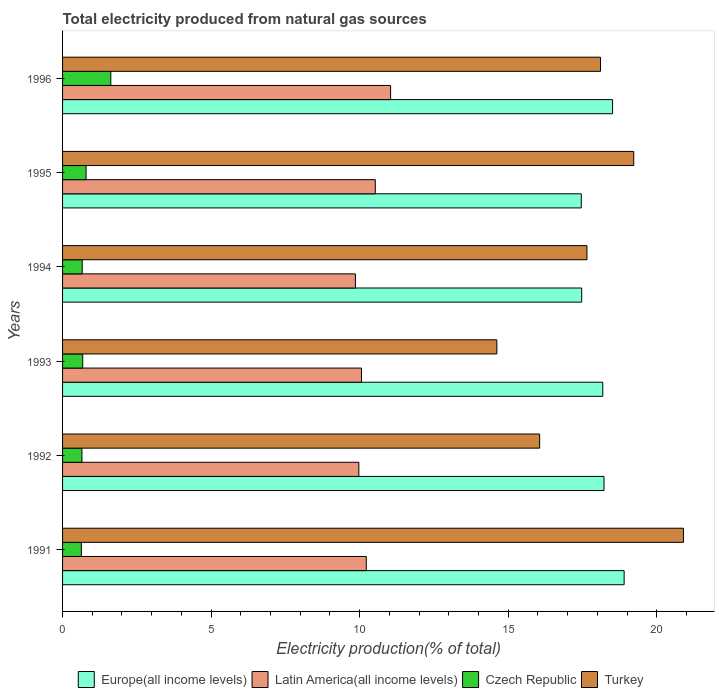How many different coloured bars are there?
Your answer should be very brief. 4. How many groups of bars are there?
Provide a short and direct response. 6. Are the number of bars per tick equal to the number of legend labels?
Your answer should be very brief. Yes. Are the number of bars on each tick of the Y-axis equal?
Your answer should be very brief. Yes. How many bars are there on the 3rd tick from the top?
Ensure brevity in your answer.  4. How many bars are there on the 2nd tick from the bottom?
Provide a short and direct response. 4. What is the label of the 1st group of bars from the top?
Offer a terse response. 1996. In how many cases, is the number of bars for a given year not equal to the number of legend labels?
Offer a very short reply. 0. What is the total electricity produced in Latin America(all income levels) in 1991?
Your answer should be very brief. 10.22. Across all years, what is the maximum total electricity produced in Czech Republic?
Offer a very short reply. 1.62. Across all years, what is the minimum total electricity produced in Turkey?
Your response must be concise. 14.62. In which year was the total electricity produced in Latin America(all income levels) minimum?
Offer a terse response. 1994. What is the total total electricity produced in Latin America(all income levels) in the graph?
Provide a short and direct response. 61.68. What is the difference between the total electricity produced in Turkey in 1991 and that in 1994?
Give a very brief answer. 3.25. What is the difference between the total electricity produced in Latin America(all income levels) in 1994 and the total electricity produced in Czech Republic in 1996?
Provide a succinct answer. 8.23. What is the average total electricity produced in Turkey per year?
Your answer should be compact. 17.76. In the year 1991, what is the difference between the total electricity produced in Czech Republic and total electricity produced in Europe(all income levels)?
Your answer should be compact. -18.27. In how many years, is the total electricity produced in Turkey greater than 12 %?
Ensure brevity in your answer.  6. What is the ratio of the total electricity produced in Latin America(all income levels) in 1992 to that in 1994?
Keep it short and to the point. 1.01. Is the difference between the total electricity produced in Czech Republic in 1991 and 1996 greater than the difference between the total electricity produced in Europe(all income levels) in 1991 and 1996?
Ensure brevity in your answer.  No. What is the difference between the highest and the second highest total electricity produced in Czech Republic?
Offer a very short reply. 0.83. What is the difference between the highest and the lowest total electricity produced in Czech Republic?
Provide a succinct answer. 0.99. In how many years, is the total electricity produced in Latin America(all income levels) greater than the average total electricity produced in Latin America(all income levels) taken over all years?
Provide a short and direct response. 2. Is it the case that in every year, the sum of the total electricity produced in Latin America(all income levels) and total electricity produced in Czech Republic is greater than the sum of total electricity produced in Turkey and total electricity produced in Europe(all income levels)?
Provide a short and direct response. No. What does the 2nd bar from the top in 1991 represents?
Give a very brief answer. Czech Republic. What does the 1st bar from the bottom in 1994 represents?
Your answer should be very brief. Europe(all income levels). What is the difference between two consecutive major ticks on the X-axis?
Your answer should be very brief. 5. Are the values on the major ticks of X-axis written in scientific E-notation?
Provide a short and direct response. No. How many legend labels are there?
Your answer should be very brief. 4. What is the title of the graph?
Keep it short and to the point. Total electricity produced from natural gas sources. What is the label or title of the X-axis?
Give a very brief answer. Electricity production(% of total). What is the Electricity production(% of total) of Europe(all income levels) in 1991?
Make the answer very short. 18.9. What is the Electricity production(% of total) of Latin America(all income levels) in 1991?
Keep it short and to the point. 10.22. What is the Electricity production(% of total) in Czech Republic in 1991?
Give a very brief answer. 0.63. What is the Electricity production(% of total) of Turkey in 1991?
Offer a very short reply. 20.9. What is the Electricity production(% of total) of Europe(all income levels) in 1992?
Make the answer very short. 18.22. What is the Electricity production(% of total) in Latin America(all income levels) in 1992?
Your answer should be very brief. 9.97. What is the Electricity production(% of total) of Czech Republic in 1992?
Your response must be concise. 0.65. What is the Electricity production(% of total) of Turkey in 1992?
Your answer should be compact. 16.06. What is the Electricity production(% of total) of Europe(all income levels) in 1993?
Offer a terse response. 18.18. What is the Electricity production(% of total) of Latin America(all income levels) in 1993?
Keep it short and to the point. 10.06. What is the Electricity production(% of total) in Czech Republic in 1993?
Keep it short and to the point. 0.68. What is the Electricity production(% of total) of Turkey in 1993?
Keep it short and to the point. 14.62. What is the Electricity production(% of total) of Europe(all income levels) in 1994?
Your response must be concise. 17.47. What is the Electricity production(% of total) of Latin America(all income levels) in 1994?
Make the answer very short. 9.86. What is the Electricity production(% of total) in Czech Republic in 1994?
Provide a succinct answer. 0.66. What is the Electricity production(% of total) in Turkey in 1994?
Your response must be concise. 17.65. What is the Electricity production(% of total) of Europe(all income levels) in 1995?
Give a very brief answer. 17.46. What is the Electricity production(% of total) of Latin America(all income levels) in 1995?
Make the answer very short. 10.53. What is the Electricity production(% of total) in Czech Republic in 1995?
Provide a succinct answer. 0.79. What is the Electricity production(% of total) in Turkey in 1995?
Make the answer very short. 19.22. What is the Electricity production(% of total) of Europe(all income levels) in 1996?
Your response must be concise. 18.51. What is the Electricity production(% of total) in Latin America(all income levels) in 1996?
Ensure brevity in your answer.  11.04. What is the Electricity production(% of total) of Czech Republic in 1996?
Your answer should be very brief. 1.62. What is the Electricity production(% of total) in Turkey in 1996?
Make the answer very short. 18.1. Across all years, what is the maximum Electricity production(% of total) in Europe(all income levels)?
Make the answer very short. 18.9. Across all years, what is the maximum Electricity production(% of total) in Latin America(all income levels)?
Your response must be concise. 11.04. Across all years, what is the maximum Electricity production(% of total) in Czech Republic?
Your answer should be very brief. 1.62. Across all years, what is the maximum Electricity production(% of total) in Turkey?
Offer a terse response. 20.9. Across all years, what is the minimum Electricity production(% of total) of Europe(all income levels)?
Offer a very short reply. 17.46. Across all years, what is the minimum Electricity production(% of total) in Latin America(all income levels)?
Ensure brevity in your answer.  9.86. Across all years, what is the minimum Electricity production(% of total) of Czech Republic?
Ensure brevity in your answer.  0.63. Across all years, what is the minimum Electricity production(% of total) in Turkey?
Your answer should be compact. 14.62. What is the total Electricity production(% of total) in Europe(all income levels) in the graph?
Make the answer very short. 108.74. What is the total Electricity production(% of total) in Latin America(all income levels) in the graph?
Offer a terse response. 61.68. What is the total Electricity production(% of total) in Czech Republic in the graph?
Provide a short and direct response. 5.04. What is the total Electricity production(% of total) in Turkey in the graph?
Keep it short and to the point. 106.54. What is the difference between the Electricity production(% of total) in Europe(all income levels) in 1991 and that in 1992?
Provide a succinct answer. 0.68. What is the difference between the Electricity production(% of total) in Latin America(all income levels) in 1991 and that in 1992?
Give a very brief answer. 0.25. What is the difference between the Electricity production(% of total) in Czech Republic in 1991 and that in 1992?
Keep it short and to the point. -0.02. What is the difference between the Electricity production(% of total) of Turkey in 1991 and that in 1992?
Make the answer very short. 4.84. What is the difference between the Electricity production(% of total) in Europe(all income levels) in 1991 and that in 1993?
Your response must be concise. 0.72. What is the difference between the Electricity production(% of total) of Latin America(all income levels) in 1991 and that in 1993?
Make the answer very short. 0.16. What is the difference between the Electricity production(% of total) in Czech Republic in 1991 and that in 1993?
Offer a very short reply. -0.05. What is the difference between the Electricity production(% of total) of Turkey in 1991 and that in 1993?
Provide a short and direct response. 6.28. What is the difference between the Electricity production(% of total) of Europe(all income levels) in 1991 and that in 1994?
Ensure brevity in your answer.  1.43. What is the difference between the Electricity production(% of total) of Latin America(all income levels) in 1991 and that in 1994?
Your answer should be very brief. 0.37. What is the difference between the Electricity production(% of total) in Czech Republic in 1991 and that in 1994?
Your answer should be very brief. -0.03. What is the difference between the Electricity production(% of total) in Turkey in 1991 and that in 1994?
Your answer should be compact. 3.25. What is the difference between the Electricity production(% of total) in Europe(all income levels) in 1991 and that in 1995?
Your response must be concise. 1.44. What is the difference between the Electricity production(% of total) of Latin America(all income levels) in 1991 and that in 1995?
Give a very brief answer. -0.3. What is the difference between the Electricity production(% of total) of Czech Republic in 1991 and that in 1995?
Your response must be concise. -0.16. What is the difference between the Electricity production(% of total) in Turkey in 1991 and that in 1995?
Offer a terse response. 1.67. What is the difference between the Electricity production(% of total) in Europe(all income levels) in 1991 and that in 1996?
Provide a short and direct response. 0.39. What is the difference between the Electricity production(% of total) of Latin America(all income levels) in 1991 and that in 1996?
Your response must be concise. -0.82. What is the difference between the Electricity production(% of total) of Czech Republic in 1991 and that in 1996?
Provide a succinct answer. -0.99. What is the difference between the Electricity production(% of total) of Turkey in 1991 and that in 1996?
Keep it short and to the point. 2.79. What is the difference between the Electricity production(% of total) of Europe(all income levels) in 1992 and that in 1993?
Your response must be concise. 0.04. What is the difference between the Electricity production(% of total) of Latin America(all income levels) in 1992 and that in 1993?
Make the answer very short. -0.09. What is the difference between the Electricity production(% of total) in Czech Republic in 1992 and that in 1993?
Offer a terse response. -0.03. What is the difference between the Electricity production(% of total) of Turkey in 1992 and that in 1993?
Your answer should be very brief. 1.44. What is the difference between the Electricity production(% of total) in Europe(all income levels) in 1992 and that in 1994?
Offer a terse response. 0.75. What is the difference between the Electricity production(% of total) of Latin America(all income levels) in 1992 and that in 1994?
Provide a succinct answer. 0.12. What is the difference between the Electricity production(% of total) of Czech Republic in 1992 and that in 1994?
Your answer should be compact. -0.01. What is the difference between the Electricity production(% of total) in Turkey in 1992 and that in 1994?
Provide a short and direct response. -1.59. What is the difference between the Electricity production(% of total) in Europe(all income levels) in 1992 and that in 1995?
Offer a terse response. 0.77. What is the difference between the Electricity production(% of total) of Latin America(all income levels) in 1992 and that in 1995?
Provide a succinct answer. -0.55. What is the difference between the Electricity production(% of total) of Czech Republic in 1992 and that in 1995?
Provide a short and direct response. -0.14. What is the difference between the Electricity production(% of total) in Turkey in 1992 and that in 1995?
Your answer should be very brief. -3.17. What is the difference between the Electricity production(% of total) in Europe(all income levels) in 1992 and that in 1996?
Your answer should be compact. -0.29. What is the difference between the Electricity production(% of total) of Latin America(all income levels) in 1992 and that in 1996?
Your response must be concise. -1.07. What is the difference between the Electricity production(% of total) of Czech Republic in 1992 and that in 1996?
Offer a very short reply. -0.97. What is the difference between the Electricity production(% of total) of Turkey in 1992 and that in 1996?
Your answer should be compact. -2.05. What is the difference between the Electricity production(% of total) of Europe(all income levels) in 1993 and that in 1994?
Your response must be concise. 0.71. What is the difference between the Electricity production(% of total) of Latin America(all income levels) in 1993 and that in 1994?
Your response must be concise. 0.2. What is the difference between the Electricity production(% of total) in Czech Republic in 1993 and that in 1994?
Provide a short and direct response. 0.02. What is the difference between the Electricity production(% of total) of Turkey in 1993 and that in 1994?
Give a very brief answer. -3.03. What is the difference between the Electricity production(% of total) in Europe(all income levels) in 1993 and that in 1995?
Keep it short and to the point. 0.72. What is the difference between the Electricity production(% of total) in Latin America(all income levels) in 1993 and that in 1995?
Your answer should be very brief. -0.47. What is the difference between the Electricity production(% of total) of Czech Republic in 1993 and that in 1995?
Offer a very short reply. -0.11. What is the difference between the Electricity production(% of total) in Turkey in 1993 and that in 1995?
Your response must be concise. -4.61. What is the difference between the Electricity production(% of total) in Europe(all income levels) in 1993 and that in 1996?
Give a very brief answer. -0.33. What is the difference between the Electricity production(% of total) in Latin America(all income levels) in 1993 and that in 1996?
Your answer should be compact. -0.98. What is the difference between the Electricity production(% of total) in Czech Republic in 1993 and that in 1996?
Provide a short and direct response. -0.94. What is the difference between the Electricity production(% of total) in Turkey in 1993 and that in 1996?
Give a very brief answer. -3.49. What is the difference between the Electricity production(% of total) in Europe(all income levels) in 1994 and that in 1995?
Provide a short and direct response. 0.01. What is the difference between the Electricity production(% of total) of Latin America(all income levels) in 1994 and that in 1995?
Give a very brief answer. -0.67. What is the difference between the Electricity production(% of total) in Czech Republic in 1994 and that in 1995?
Give a very brief answer. -0.13. What is the difference between the Electricity production(% of total) in Turkey in 1994 and that in 1995?
Make the answer very short. -1.57. What is the difference between the Electricity production(% of total) in Europe(all income levels) in 1994 and that in 1996?
Offer a very short reply. -1.04. What is the difference between the Electricity production(% of total) in Latin America(all income levels) in 1994 and that in 1996?
Offer a terse response. -1.18. What is the difference between the Electricity production(% of total) of Czech Republic in 1994 and that in 1996?
Offer a terse response. -0.96. What is the difference between the Electricity production(% of total) in Turkey in 1994 and that in 1996?
Keep it short and to the point. -0.46. What is the difference between the Electricity production(% of total) in Europe(all income levels) in 1995 and that in 1996?
Provide a succinct answer. -1.05. What is the difference between the Electricity production(% of total) in Latin America(all income levels) in 1995 and that in 1996?
Provide a short and direct response. -0.52. What is the difference between the Electricity production(% of total) in Czech Republic in 1995 and that in 1996?
Your answer should be compact. -0.83. What is the difference between the Electricity production(% of total) of Turkey in 1995 and that in 1996?
Make the answer very short. 1.12. What is the difference between the Electricity production(% of total) of Europe(all income levels) in 1991 and the Electricity production(% of total) of Latin America(all income levels) in 1992?
Offer a very short reply. 8.93. What is the difference between the Electricity production(% of total) of Europe(all income levels) in 1991 and the Electricity production(% of total) of Czech Republic in 1992?
Offer a terse response. 18.25. What is the difference between the Electricity production(% of total) of Europe(all income levels) in 1991 and the Electricity production(% of total) of Turkey in 1992?
Your answer should be very brief. 2.84. What is the difference between the Electricity production(% of total) of Latin America(all income levels) in 1991 and the Electricity production(% of total) of Czech Republic in 1992?
Offer a very short reply. 9.57. What is the difference between the Electricity production(% of total) of Latin America(all income levels) in 1991 and the Electricity production(% of total) of Turkey in 1992?
Your answer should be compact. -5.84. What is the difference between the Electricity production(% of total) of Czech Republic in 1991 and the Electricity production(% of total) of Turkey in 1992?
Make the answer very short. -15.43. What is the difference between the Electricity production(% of total) of Europe(all income levels) in 1991 and the Electricity production(% of total) of Latin America(all income levels) in 1993?
Provide a short and direct response. 8.84. What is the difference between the Electricity production(% of total) of Europe(all income levels) in 1991 and the Electricity production(% of total) of Czech Republic in 1993?
Your answer should be very brief. 18.22. What is the difference between the Electricity production(% of total) in Europe(all income levels) in 1991 and the Electricity production(% of total) in Turkey in 1993?
Give a very brief answer. 4.28. What is the difference between the Electricity production(% of total) of Latin America(all income levels) in 1991 and the Electricity production(% of total) of Czech Republic in 1993?
Provide a succinct answer. 9.54. What is the difference between the Electricity production(% of total) in Latin America(all income levels) in 1991 and the Electricity production(% of total) in Turkey in 1993?
Provide a succinct answer. -4.39. What is the difference between the Electricity production(% of total) in Czech Republic in 1991 and the Electricity production(% of total) in Turkey in 1993?
Give a very brief answer. -13.98. What is the difference between the Electricity production(% of total) of Europe(all income levels) in 1991 and the Electricity production(% of total) of Latin America(all income levels) in 1994?
Give a very brief answer. 9.04. What is the difference between the Electricity production(% of total) in Europe(all income levels) in 1991 and the Electricity production(% of total) in Czech Republic in 1994?
Keep it short and to the point. 18.24. What is the difference between the Electricity production(% of total) in Europe(all income levels) in 1991 and the Electricity production(% of total) in Turkey in 1994?
Make the answer very short. 1.25. What is the difference between the Electricity production(% of total) of Latin America(all income levels) in 1991 and the Electricity production(% of total) of Czech Republic in 1994?
Your answer should be very brief. 9.56. What is the difference between the Electricity production(% of total) of Latin America(all income levels) in 1991 and the Electricity production(% of total) of Turkey in 1994?
Provide a succinct answer. -7.43. What is the difference between the Electricity production(% of total) in Czech Republic in 1991 and the Electricity production(% of total) in Turkey in 1994?
Offer a terse response. -17.02. What is the difference between the Electricity production(% of total) of Europe(all income levels) in 1991 and the Electricity production(% of total) of Latin America(all income levels) in 1995?
Your answer should be very brief. 8.37. What is the difference between the Electricity production(% of total) in Europe(all income levels) in 1991 and the Electricity production(% of total) in Czech Republic in 1995?
Keep it short and to the point. 18.11. What is the difference between the Electricity production(% of total) in Europe(all income levels) in 1991 and the Electricity production(% of total) in Turkey in 1995?
Offer a terse response. -0.32. What is the difference between the Electricity production(% of total) of Latin America(all income levels) in 1991 and the Electricity production(% of total) of Czech Republic in 1995?
Your answer should be very brief. 9.43. What is the difference between the Electricity production(% of total) in Latin America(all income levels) in 1991 and the Electricity production(% of total) in Turkey in 1995?
Offer a very short reply. -9. What is the difference between the Electricity production(% of total) of Czech Republic in 1991 and the Electricity production(% of total) of Turkey in 1995?
Give a very brief answer. -18.59. What is the difference between the Electricity production(% of total) of Europe(all income levels) in 1991 and the Electricity production(% of total) of Latin America(all income levels) in 1996?
Give a very brief answer. 7.86. What is the difference between the Electricity production(% of total) of Europe(all income levels) in 1991 and the Electricity production(% of total) of Czech Republic in 1996?
Make the answer very short. 17.28. What is the difference between the Electricity production(% of total) of Europe(all income levels) in 1991 and the Electricity production(% of total) of Turkey in 1996?
Your response must be concise. 0.8. What is the difference between the Electricity production(% of total) of Latin America(all income levels) in 1991 and the Electricity production(% of total) of Czech Republic in 1996?
Provide a succinct answer. 8.6. What is the difference between the Electricity production(% of total) in Latin America(all income levels) in 1991 and the Electricity production(% of total) in Turkey in 1996?
Provide a short and direct response. -7.88. What is the difference between the Electricity production(% of total) of Czech Republic in 1991 and the Electricity production(% of total) of Turkey in 1996?
Give a very brief answer. -17.47. What is the difference between the Electricity production(% of total) of Europe(all income levels) in 1992 and the Electricity production(% of total) of Latin America(all income levels) in 1993?
Provide a succinct answer. 8.16. What is the difference between the Electricity production(% of total) in Europe(all income levels) in 1992 and the Electricity production(% of total) in Czech Republic in 1993?
Offer a very short reply. 17.54. What is the difference between the Electricity production(% of total) in Europe(all income levels) in 1992 and the Electricity production(% of total) in Turkey in 1993?
Your response must be concise. 3.61. What is the difference between the Electricity production(% of total) in Latin America(all income levels) in 1992 and the Electricity production(% of total) in Czech Republic in 1993?
Your answer should be very brief. 9.29. What is the difference between the Electricity production(% of total) of Latin America(all income levels) in 1992 and the Electricity production(% of total) of Turkey in 1993?
Your answer should be compact. -4.64. What is the difference between the Electricity production(% of total) of Czech Republic in 1992 and the Electricity production(% of total) of Turkey in 1993?
Offer a terse response. -13.96. What is the difference between the Electricity production(% of total) of Europe(all income levels) in 1992 and the Electricity production(% of total) of Latin America(all income levels) in 1994?
Ensure brevity in your answer.  8.37. What is the difference between the Electricity production(% of total) of Europe(all income levels) in 1992 and the Electricity production(% of total) of Czech Republic in 1994?
Give a very brief answer. 17.56. What is the difference between the Electricity production(% of total) in Europe(all income levels) in 1992 and the Electricity production(% of total) in Turkey in 1994?
Your answer should be compact. 0.57. What is the difference between the Electricity production(% of total) of Latin America(all income levels) in 1992 and the Electricity production(% of total) of Czech Republic in 1994?
Make the answer very short. 9.31. What is the difference between the Electricity production(% of total) of Latin America(all income levels) in 1992 and the Electricity production(% of total) of Turkey in 1994?
Offer a very short reply. -7.68. What is the difference between the Electricity production(% of total) in Czech Republic in 1992 and the Electricity production(% of total) in Turkey in 1994?
Provide a succinct answer. -17. What is the difference between the Electricity production(% of total) in Europe(all income levels) in 1992 and the Electricity production(% of total) in Latin America(all income levels) in 1995?
Provide a succinct answer. 7.7. What is the difference between the Electricity production(% of total) in Europe(all income levels) in 1992 and the Electricity production(% of total) in Czech Republic in 1995?
Ensure brevity in your answer.  17.43. What is the difference between the Electricity production(% of total) in Europe(all income levels) in 1992 and the Electricity production(% of total) in Turkey in 1995?
Make the answer very short. -1. What is the difference between the Electricity production(% of total) in Latin America(all income levels) in 1992 and the Electricity production(% of total) in Czech Republic in 1995?
Make the answer very short. 9.18. What is the difference between the Electricity production(% of total) of Latin America(all income levels) in 1992 and the Electricity production(% of total) of Turkey in 1995?
Provide a short and direct response. -9.25. What is the difference between the Electricity production(% of total) of Czech Republic in 1992 and the Electricity production(% of total) of Turkey in 1995?
Your answer should be compact. -18.57. What is the difference between the Electricity production(% of total) of Europe(all income levels) in 1992 and the Electricity production(% of total) of Latin America(all income levels) in 1996?
Your response must be concise. 7.18. What is the difference between the Electricity production(% of total) of Europe(all income levels) in 1992 and the Electricity production(% of total) of Czech Republic in 1996?
Your response must be concise. 16.6. What is the difference between the Electricity production(% of total) of Europe(all income levels) in 1992 and the Electricity production(% of total) of Turkey in 1996?
Your answer should be very brief. 0.12. What is the difference between the Electricity production(% of total) in Latin America(all income levels) in 1992 and the Electricity production(% of total) in Czech Republic in 1996?
Provide a short and direct response. 8.35. What is the difference between the Electricity production(% of total) in Latin America(all income levels) in 1992 and the Electricity production(% of total) in Turkey in 1996?
Offer a very short reply. -8.13. What is the difference between the Electricity production(% of total) in Czech Republic in 1992 and the Electricity production(% of total) in Turkey in 1996?
Your answer should be very brief. -17.45. What is the difference between the Electricity production(% of total) of Europe(all income levels) in 1993 and the Electricity production(% of total) of Latin America(all income levels) in 1994?
Your answer should be very brief. 8.33. What is the difference between the Electricity production(% of total) of Europe(all income levels) in 1993 and the Electricity production(% of total) of Czech Republic in 1994?
Offer a very short reply. 17.52. What is the difference between the Electricity production(% of total) of Europe(all income levels) in 1993 and the Electricity production(% of total) of Turkey in 1994?
Give a very brief answer. 0.53. What is the difference between the Electricity production(% of total) of Latin America(all income levels) in 1993 and the Electricity production(% of total) of Czech Republic in 1994?
Ensure brevity in your answer.  9.4. What is the difference between the Electricity production(% of total) in Latin America(all income levels) in 1993 and the Electricity production(% of total) in Turkey in 1994?
Offer a terse response. -7.59. What is the difference between the Electricity production(% of total) of Czech Republic in 1993 and the Electricity production(% of total) of Turkey in 1994?
Your answer should be compact. -16.97. What is the difference between the Electricity production(% of total) of Europe(all income levels) in 1993 and the Electricity production(% of total) of Latin America(all income levels) in 1995?
Provide a succinct answer. 7.66. What is the difference between the Electricity production(% of total) in Europe(all income levels) in 1993 and the Electricity production(% of total) in Czech Republic in 1995?
Your answer should be very brief. 17.39. What is the difference between the Electricity production(% of total) of Europe(all income levels) in 1993 and the Electricity production(% of total) of Turkey in 1995?
Give a very brief answer. -1.04. What is the difference between the Electricity production(% of total) in Latin America(all income levels) in 1993 and the Electricity production(% of total) in Czech Republic in 1995?
Ensure brevity in your answer.  9.27. What is the difference between the Electricity production(% of total) in Latin America(all income levels) in 1993 and the Electricity production(% of total) in Turkey in 1995?
Your answer should be compact. -9.16. What is the difference between the Electricity production(% of total) of Czech Republic in 1993 and the Electricity production(% of total) of Turkey in 1995?
Keep it short and to the point. -18.54. What is the difference between the Electricity production(% of total) in Europe(all income levels) in 1993 and the Electricity production(% of total) in Latin America(all income levels) in 1996?
Ensure brevity in your answer.  7.14. What is the difference between the Electricity production(% of total) of Europe(all income levels) in 1993 and the Electricity production(% of total) of Czech Republic in 1996?
Your answer should be very brief. 16.56. What is the difference between the Electricity production(% of total) in Europe(all income levels) in 1993 and the Electricity production(% of total) in Turkey in 1996?
Make the answer very short. 0.08. What is the difference between the Electricity production(% of total) of Latin America(all income levels) in 1993 and the Electricity production(% of total) of Czech Republic in 1996?
Keep it short and to the point. 8.44. What is the difference between the Electricity production(% of total) in Latin America(all income levels) in 1993 and the Electricity production(% of total) in Turkey in 1996?
Provide a short and direct response. -8.04. What is the difference between the Electricity production(% of total) in Czech Republic in 1993 and the Electricity production(% of total) in Turkey in 1996?
Provide a succinct answer. -17.43. What is the difference between the Electricity production(% of total) of Europe(all income levels) in 1994 and the Electricity production(% of total) of Latin America(all income levels) in 1995?
Your answer should be very brief. 6.95. What is the difference between the Electricity production(% of total) in Europe(all income levels) in 1994 and the Electricity production(% of total) in Czech Republic in 1995?
Make the answer very short. 16.68. What is the difference between the Electricity production(% of total) of Europe(all income levels) in 1994 and the Electricity production(% of total) of Turkey in 1995?
Make the answer very short. -1.75. What is the difference between the Electricity production(% of total) of Latin America(all income levels) in 1994 and the Electricity production(% of total) of Czech Republic in 1995?
Ensure brevity in your answer.  9.07. What is the difference between the Electricity production(% of total) in Latin America(all income levels) in 1994 and the Electricity production(% of total) in Turkey in 1995?
Make the answer very short. -9.37. What is the difference between the Electricity production(% of total) of Czech Republic in 1994 and the Electricity production(% of total) of Turkey in 1995?
Provide a short and direct response. -18.56. What is the difference between the Electricity production(% of total) of Europe(all income levels) in 1994 and the Electricity production(% of total) of Latin America(all income levels) in 1996?
Ensure brevity in your answer.  6.43. What is the difference between the Electricity production(% of total) in Europe(all income levels) in 1994 and the Electricity production(% of total) in Czech Republic in 1996?
Make the answer very short. 15.85. What is the difference between the Electricity production(% of total) of Europe(all income levels) in 1994 and the Electricity production(% of total) of Turkey in 1996?
Your response must be concise. -0.63. What is the difference between the Electricity production(% of total) in Latin America(all income levels) in 1994 and the Electricity production(% of total) in Czech Republic in 1996?
Give a very brief answer. 8.23. What is the difference between the Electricity production(% of total) in Latin America(all income levels) in 1994 and the Electricity production(% of total) in Turkey in 1996?
Ensure brevity in your answer.  -8.25. What is the difference between the Electricity production(% of total) of Czech Republic in 1994 and the Electricity production(% of total) of Turkey in 1996?
Your answer should be very brief. -17.44. What is the difference between the Electricity production(% of total) in Europe(all income levels) in 1995 and the Electricity production(% of total) in Latin America(all income levels) in 1996?
Offer a terse response. 6.42. What is the difference between the Electricity production(% of total) in Europe(all income levels) in 1995 and the Electricity production(% of total) in Czech Republic in 1996?
Your answer should be very brief. 15.83. What is the difference between the Electricity production(% of total) in Europe(all income levels) in 1995 and the Electricity production(% of total) in Turkey in 1996?
Offer a very short reply. -0.65. What is the difference between the Electricity production(% of total) in Latin America(all income levels) in 1995 and the Electricity production(% of total) in Czech Republic in 1996?
Your response must be concise. 8.9. What is the difference between the Electricity production(% of total) of Latin America(all income levels) in 1995 and the Electricity production(% of total) of Turkey in 1996?
Your response must be concise. -7.58. What is the difference between the Electricity production(% of total) of Czech Republic in 1995 and the Electricity production(% of total) of Turkey in 1996?
Your answer should be very brief. -17.31. What is the average Electricity production(% of total) of Europe(all income levels) per year?
Your response must be concise. 18.12. What is the average Electricity production(% of total) in Latin America(all income levels) per year?
Keep it short and to the point. 10.28. What is the average Electricity production(% of total) in Czech Republic per year?
Offer a terse response. 0.84. What is the average Electricity production(% of total) of Turkey per year?
Your answer should be compact. 17.76. In the year 1991, what is the difference between the Electricity production(% of total) of Europe(all income levels) and Electricity production(% of total) of Latin America(all income levels)?
Make the answer very short. 8.68. In the year 1991, what is the difference between the Electricity production(% of total) in Europe(all income levels) and Electricity production(% of total) in Czech Republic?
Your answer should be compact. 18.27. In the year 1991, what is the difference between the Electricity production(% of total) in Europe(all income levels) and Electricity production(% of total) in Turkey?
Provide a short and direct response. -2. In the year 1991, what is the difference between the Electricity production(% of total) of Latin America(all income levels) and Electricity production(% of total) of Czech Republic?
Your response must be concise. 9.59. In the year 1991, what is the difference between the Electricity production(% of total) of Latin America(all income levels) and Electricity production(% of total) of Turkey?
Give a very brief answer. -10.67. In the year 1991, what is the difference between the Electricity production(% of total) of Czech Republic and Electricity production(% of total) of Turkey?
Give a very brief answer. -20.26. In the year 1992, what is the difference between the Electricity production(% of total) of Europe(all income levels) and Electricity production(% of total) of Latin America(all income levels)?
Offer a very short reply. 8.25. In the year 1992, what is the difference between the Electricity production(% of total) of Europe(all income levels) and Electricity production(% of total) of Czech Republic?
Provide a succinct answer. 17.57. In the year 1992, what is the difference between the Electricity production(% of total) in Europe(all income levels) and Electricity production(% of total) in Turkey?
Ensure brevity in your answer.  2.17. In the year 1992, what is the difference between the Electricity production(% of total) of Latin America(all income levels) and Electricity production(% of total) of Czech Republic?
Offer a very short reply. 9.32. In the year 1992, what is the difference between the Electricity production(% of total) in Latin America(all income levels) and Electricity production(% of total) in Turkey?
Offer a very short reply. -6.09. In the year 1992, what is the difference between the Electricity production(% of total) in Czech Republic and Electricity production(% of total) in Turkey?
Make the answer very short. -15.4. In the year 1993, what is the difference between the Electricity production(% of total) in Europe(all income levels) and Electricity production(% of total) in Latin America(all income levels)?
Make the answer very short. 8.12. In the year 1993, what is the difference between the Electricity production(% of total) in Europe(all income levels) and Electricity production(% of total) in Czech Republic?
Your answer should be very brief. 17.5. In the year 1993, what is the difference between the Electricity production(% of total) of Europe(all income levels) and Electricity production(% of total) of Turkey?
Offer a very short reply. 3.56. In the year 1993, what is the difference between the Electricity production(% of total) of Latin America(all income levels) and Electricity production(% of total) of Czech Republic?
Give a very brief answer. 9.38. In the year 1993, what is the difference between the Electricity production(% of total) in Latin America(all income levels) and Electricity production(% of total) in Turkey?
Provide a succinct answer. -4.56. In the year 1993, what is the difference between the Electricity production(% of total) in Czech Republic and Electricity production(% of total) in Turkey?
Give a very brief answer. -13.94. In the year 1994, what is the difference between the Electricity production(% of total) of Europe(all income levels) and Electricity production(% of total) of Latin America(all income levels)?
Provide a succinct answer. 7.62. In the year 1994, what is the difference between the Electricity production(% of total) in Europe(all income levels) and Electricity production(% of total) in Czech Republic?
Keep it short and to the point. 16.81. In the year 1994, what is the difference between the Electricity production(% of total) of Europe(all income levels) and Electricity production(% of total) of Turkey?
Give a very brief answer. -0.18. In the year 1994, what is the difference between the Electricity production(% of total) in Latin America(all income levels) and Electricity production(% of total) in Czech Republic?
Your answer should be very brief. 9.19. In the year 1994, what is the difference between the Electricity production(% of total) of Latin America(all income levels) and Electricity production(% of total) of Turkey?
Make the answer very short. -7.79. In the year 1994, what is the difference between the Electricity production(% of total) in Czech Republic and Electricity production(% of total) in Turkey?
Provide a succinct answer. -16.99. In the year 1995, what is the difference between the Electricity production(% of total) in Europe(all income levels) and Electricity production(% of total) in Latin America(all income levels)?
Offer a terse response. 6.93. In the year 1995, what is the difference between the Electricity production(% of total) in Europe(all income levels) and Electricity production(% of total) in Czech Republic?
Offer a very short reply. 16.67. In the year 1995, what is the difference between the Electricity production(% of total) of Europe(all income levels) and Electricity production(% of total) of Turkey?
Make the answer very short. -1.77. In the year 1995, what is the difference between the Electricity production(% of total) of Latin America(all income levels) and Electricity production(% of total) of Czech Republic?
Give a very brief answer. 9.73. In the year 1995, what is the difference between the Electricity production(% of total) of Latin America(all income levels) and Electricity production(% of total) of Turkey?
Ensure brevity in your answer.  -8.7. In the year 1995, what is the difference between the Electricity production(% of total) of Czech Republic and Electricity production(% of total) of Turkey?
Your response must be concise. -18.43. In the year 1996, what is the difference between the Electricity production(% of total) of Europe(all income levels) and Electricity production(% of total) of Latin America(all income levels)?
Your response must be concise. 7.47. In the year 1996, what is the difference between the Electricity production(% of total) of Europe(all income levels) and Electricity production(% of total) of Czech Republic?
Provide a short and direct response. 16.89. In the year 1996, what is the difference between the Electricity production(% of total) in Europe(all income levels) and Electricity production(% of total) in Turkey?
Your answer should be very brief. 0.41. In the year 1996, what is the difference between the Electricity production(% of total) of Latin America(all income levels) and Electricity production(% of total) of Czech Republic?
Give a very brief answer. 9.42. In the year 1996, what is the difference between the Electricity production(% of total) in Latin America(all income levels) and Electricity production(% of total) in Turkey?
Offer a terse response. -7.06. In the year 1996, what is the difference between the Electricity production(% of total) of Czech Republic and Electricity production(% of total) of Turkey?
Your answer should be very brief. -16.48. What is the ratio of the Electricity production(% of total) in Europe(all income levels) in 1991 to that in 1992?
Ensure brevity in your answer.  1.04. What is the ratio of the Electricity production(% of total) in Latin America(all income levels) in 1991 to that in 1992?
Your answer should be very brief. 1.03. What is the ratio of the Electricity production(% of total) in Czech Republic in 1991 to that in 1992?
Make the answer very short. 0.97. What is the ratio of the Electricity production(% of total) in Turkey in 1991 to that in 1992?
Offer a very short reply. 1.3. What is the ratio of the Electricity production(% of total) in Europe(all income levels) in 1991 to that in 1993?
Your answer should be compact. 1.04. What is the ratio of the Electricity production(% of total) in Czech Republic in 1991 to that in 1993?
Provide a short and direct response. 0.93. What is the ratio of the Electricity production(% of total) of Turkey in 1991 to that in 1993?
Offer a very short reply. 1.43. What is the ratio of the Electricity production(% of total) of Europe(all income levels) in 1991 to that in 1994?
Give a very brief answer. 1.08. What is the ratio of the Electricity production(% of total) of Latin America(all income levels) in 1991 to that in 1994?
Keep it short and to the point. 1.04. What is the ratio of the Electricity production(% of total) in Czech Republic in 1991 to that in 1994?
Ensure brevity in your answer.  0.96. What is the ratio of the Electricity production(% of total) in Turkey in 1991 to that in 1994?
Give a very brief answer. 1.18. What is the ratio of the Electricity production(% of total) of Europe(all income levels) in 1991 to that in 1995?
Your answer should be very brief. 1.08. What is the ratio of the Electricity production(% of total) of Latin America(all income levels) in 1991 to that in 1995?
Offer a very short reply. 0.97. What is the ratio of the Electricity production(% of total) of Czech Republic in 1991 to that in 1995?
Provide a short and direct response. 0.8. What is the ratio of the Electricity production(% of total) of Turkey in 1991 to that in 1995?
Offer a very short reply. 1.09. What is the ratio of the Electricity production(% of total) in Europe(all income levels) in 1991 to that in 1996?
Your answer should be compact. 1.02. What is the ratio of the Electricity production(% of total) of Latin America(all income levels) in 1991 to that in 1996?
Ensure brevity in your answer.  0.93. What is the ratio of the Electricity production(% of total) of Czech Republic in 1991 to that in 1996?
Your answer should be very brief. 0.39. What is the ratio of the Electricity production(% of total) of Turkey in 1991 to that in 1996?
Your answer should be compact. 1.15. What is the ratio of the Electricity production(% of total) of Czech Republic in 1992 to that in 1993?
Your response must be concise. 0.96. What is the ratio of the Electricity production(% of total) in Turkey in 1992 to that in 1993?
Your response must be concise. 1.1. What is the ratio of the Electricity production(% of total) in Europe(all income levels) in 1992 to that in 1994?
Provide a short and direct response. 1.04. What is the ratio of the Electricity production(% of total) of Latin America(all income levels) in 1992 to that in 1994?
Ensure brevity in your answer.  1.01. What is the ratio of the Electricity production(% of total) in Czech Republic in 1992 to that in 1994?
Ensure brevity in your answer.  0.99. What is the ratio of the Electricity production(% of total) of Turkey in 1992 to that in 1994?
Offer a terse response. 0.91. What is the ratio of the Electricity production(% of total) in Europe(all income levels) in 1992 to that in 1995?
Offer a very short reply. 1.04. What is the ratio of the Electricity production(% of total) of Czech Republic in 1992 to that in 1995?
Your response must be concise. 0.82. What is the ratio of the Electricity production(% of total) of Turkey in 1992 to that in 1995?
Your answer should be compact. 0.84. What is the ratio of the Electricity production(% of total) in Europe(all income levels) in 1992 to that in 1996?
Offer a very short reply. 0.98. What is the ratio of the Electricity production(% of total) in Latin America(all income levels) in 1992 to that in 1996?
Offer a very short reply. 0.9. What is the ratio of the Electricity production(% of total) of Czech Republic in 1992 to that in 1996?
Give a very brief answer. 0.4. What is the ratio of the Electricity production(% of total) in Turkey in 1992 to that in 1996?
Provide a short and direct response. 0.89. What is the ratio of the Electricity production(% of total) of Europe(all income levels) in 1993 to that in 1994?
Ensure brevity in your answer.  1.04. What is the ratio of the Electricity production(% of total) of Latin America(all income levels) in 1993 to that in 1994?
Ensure brevity in your answer.  1.02. What is the ratio of the Electricity production(% of total) in Czech Republic in 1993 to that in 1994?
Your answer should be very brief. 1.03. What is the ratio of the Electricity production(% of total) of Turkey in 1993 to that in 1994?
Offer a very short reply. 0.83. What is the ratio of the Electricity production(% of total) in Europe(all income levels) in 1993 to that in 1995?
Ensure brevity in your answer.  1.04. What is the ratio of the Electricity production(% of total) of Latin America(all income levels) in 1993 to that in 1995?
Make the answer very short. 0.96. What is the ratio of the Electricity production(% of total) of Czech Republic in 1993 to that in 1995?
Your response must be concise. 0.86. What is the ratio of the Electricity production(% of total) of Turkey in 1993 to that in 1995?
Ensure brevity in your answer.  0.76. What is the ratio of the Electricity production(% of total) in Europe(all income levels) in 1993 to that in 1996?
Offer a very short reply. 0.98. What is the ratio of the Electricity production(% of total) in Latin America(all income levels) in 1993 to that in 1996?
Make the answer very short. 0.91. What is the ratio of the Electricity production(% of total) of Czech Republic in 1993 to that in 1996?
Provide a succinct answer. 0.42. What is the ratio of the Electricity production(% of total) in Turkey in 1993 to that in 1996?
Offer a terse response. 0.81. What is the ratio of the Electricity production(% of total) in Latin America(all income levels) in 1994 to that in 1995?
Give a very brief answer. 0.94. What is the ratio of the Electricity production(% of total) in Czech Republic in 1994 to that in 1995?
Offer a terse response. 0.84. What is the ratio of the Electricity production(% of total) of Turkey in 1994 to that in 1995?
Offer a terse response. 0.92. What is the ratio of the Electricity production(% of total) of Europe(all income levels) in 1994 to that in 1996?
Offer a terse response. 0.94. What is the ratio of the Electricity production(% of total) in Latin America(all income levels) in 1994 to that in 1996?
Your answer should be compact. 0.89. What is the ratio of the Electricity production(% of total) in Czech Republic in 1994 to that in 1996?
Your answer should be compact. 0.41. What is the ratio of the Electricity production(% of total) of Turkey in 1994 to that in 1996?
Offer a very short reply. 0.97. What is the ratio of the Electricity production(% of total) of Europe(all income levels) in 1995 to that in 1996?
Keep it short and to the point. 0.94. What is the ratio of the Electricity production(% of total) of Latin America(all income levels) in 1995 to that in 1996?
Make the answer very short. 0.95. What is the ratio of the Electricity production(% of total) of Czech Republic in 1995 to that in 1996?
Your response must be concise. 0.49. What is the ratio of the Electricity production(% of total) in Turkey in 1995 to that in 1996?
Offer a terse response. 1.06. What is the difference between the highest and the second highest Electricity production(% of total) in Europe(all income levels)?
Your answer should be compact. 0.39. What is the difference between the highest and the second highest Electricity production(% of total) of Latin America(all income levels)?
Provide a short and direct response. 0.52. What is the difference between the highest and the second highest Electricity production(% of total) of Czech Republic?
Your answer should be compact. 0.83. What is the difference between the highest and the second highest Electricity production(% of total) in Turkey?
Make the answer very short. 1.67. What is the difference between the highest and the lowest Electricity production(% of total) in Europe(all income levels)?
Provide a short and direct response. 1.44. What is the difference between the highest and the lowest Electricity production(% of total) of Latin America(all income levels)?
Provide a short and direct response. 1.18. What is the difference between the highest and the lowest Electricity production(% of total) in Turkey?
Offer a terse response. 6.28. 